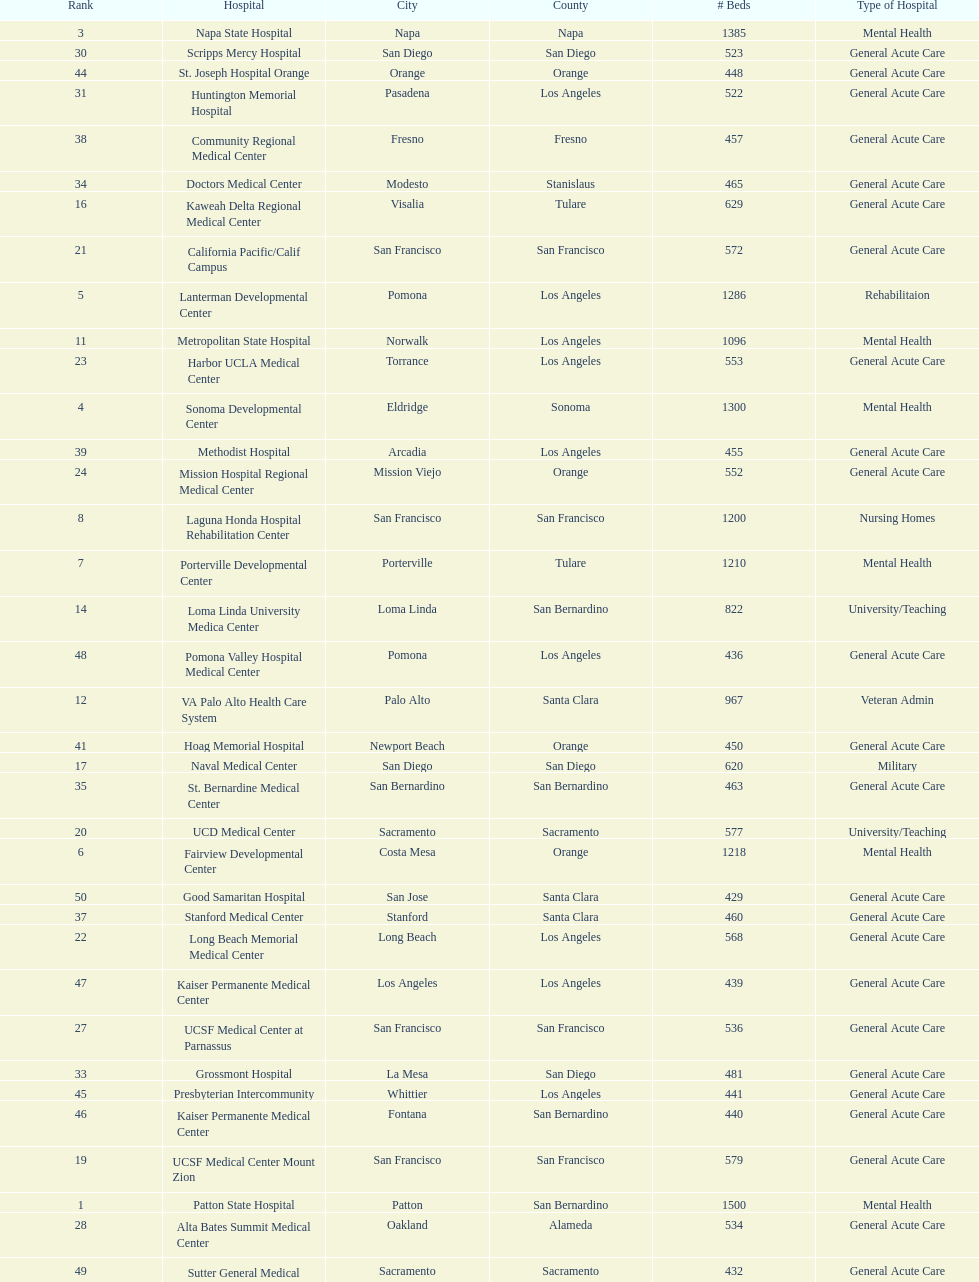Which type of hospitals are the same as grossmont hospital? General Acute Care. 